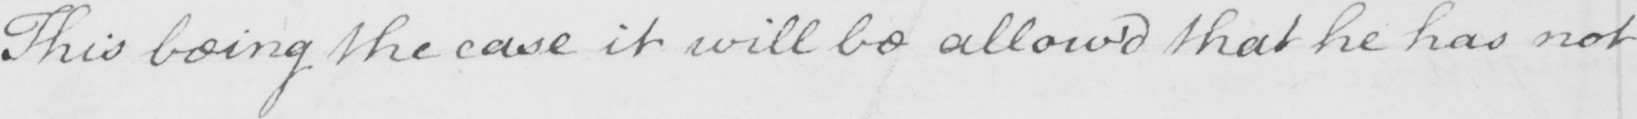Can you read and transcribe this handwriting? This being the case it will be allow ' d that he has not 